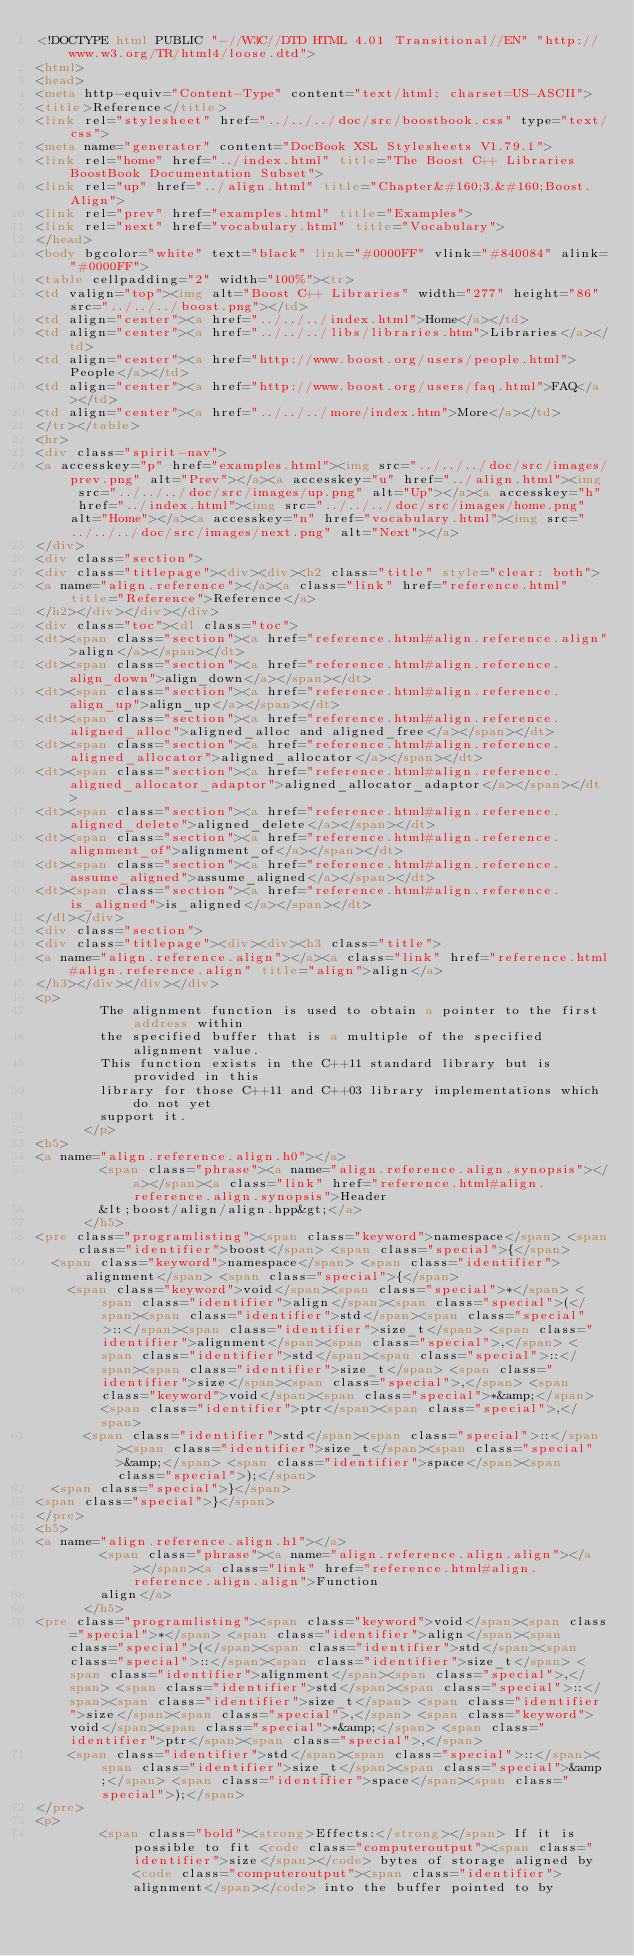Convert code to text. <code><loc_0><loc_0><loc_500><loc_500><_HTML_><!DOCTYPE html PUBLIC "-//W3C//DTD HTML 4.01 Transitional//EN" "http://www.w3.org/TR/html4/loose.dtd">
<html>
<head>
<meta http-equiv="Content-Type" content="text/html; charset=US-ASCII">
<title>Reference</title>
<link rel="stylesheet" href="../../../doc/src/boostbook.css" type="text/css">
<meta name="generator" content="DocBook XSL Stylesheets V1.79.1">
<link rel="home" href="../index.html" title="The Boost C++ Libraries BoostBook Documentation Subset">
<link rel="up" href="../align.html" title="Chapter&#160;3.&#160;Boost.Align">
<link rel="prev" href="examples.html" title="Examples">
<link rel="next" href="vocabulary.html" title="Vocabulary">
</head>
<body bgcolor="white" text="black" link="#0000FF" vlink="#840084" alink="#0000FF">
<table cellpadding="2" width="100%"><tr>
<td valign="top"><img alt="Boost C++ Libraries" width="277" height="86" src="../../../boost.png"></td>
<td align="center"><a href="../../../index.html">Home</a></td>
<td align="center"><a href="../../../libs/libraries.htm">Libraries</a></td>
<td align="center"><a href="http://www.boost.org/users/people.html">People</a></td>
<td align="center"><a href="http://www.boost.org/users/faq.html">FAQ</a></td>
<td align="center"><a href="../../../more/index.htm">More</a></td>
</tr></table>
<hr>
<div class="spirit-nav">
<a accesskey="p" href="examples.html"><img src="../../../doc/src/images/prev.png" alt="Prev"></a><a accesskey="u" href="../align.html"><img src="../../../doc/src/images/up.png" alt="Up"></a><a accesskey="h" href="../index.html"><img src="../../../doc/src/images/home.png" alt="Home"></a><a accesskey="n" href="vocabulary.html"><img src="../../../doc/src/images/next.png" alt="Next"></a>
</div>
<div class="section">
<div class="titlepage"><div><div><h2 class="title" style="clear: both">
<a name="align.reference"></a><a class="link" href="reference.html" title="Reference">Reference</a>
</h2></div></div></div>
<div class="toc"><dl class="toc">
<dt><span class="section"><a href="reference.html#align.reference.align">align</a></span></dt>
<dt><span class="section"><a href="reference.html#align.reference.align_down">align_down</a></span></dt>
<dt><span class="section"><a href="reference.html#align.reference.align_up">align_up</a></span></dt>
<dt><span class="section"><a href="reference.html#align.reference.aligned_alloc">aligned_alloc and aligned_free</a></span></dt>
<dt><span class="section"><a href="reference.html#align.reference.aligned_allocator">aligned_allocator</a></span></dt>
<dt><span class="section"><a href="reference.html#align.reference.aligned_allocator_adaptor">aligned_allocator_adaptor</a></span></dt>
<dt><span class="section"><a href="reference.html#align.reference.aligned_delete">aligned_delete</a></span></dt>
<dt><span class="section"><a href="reference.html#align.reference.alignment_of">alignment_of</a></span></dt>
<dt><span class="section"><a href="reference.html#align.reference.assume_aligned">assume_aligned</a></span></dt>
<dt><span class="section"><a href="reference.html#align.reference.is_aligned">is_aligned</a></span></dt>
</dl></div>
<div class="section">
<div class="titlepage"><div><div><h3 class="title">
<a name="align.reference.align"></a><a class="link" href="reference.html#align.reference.align" title="align">align</a>
</h3></div></div></div>
<p>
        The alignment function is used to obtain a pointer to the first address within
        the specified buffer that is a multiple of the specified alignment value.
        This function exists in the C++11 standard library but is provided in this
        library for those C++11 and C++03 library implementations which do not yet
        support it.
      </p>
<h5>
<a name="align.reference.align.h0"></a>
        <span class="phrase"><a name="align.reference.align.synopsis"></a></span><a class="link" href="reference.html#align.reference.align.synopsis">Header
        &lt;boost/align/align.hpp&gt;</a>
      </h5>
<pre class="programlisting"><span class="keyword">namespace</span> <span class="identifier">boost</span> <span class="special">{</span>
  <span class="keyword">namespace</span> <span class="identifier">alignment</span> <span class="special">{</span>
    <span class="keyword">void</span><span class="special">*</span> <span class="identifier">align</span><span class="special">(</span><span class="identifier">std</span><span class="special">::</span><span class="identifier">size_t</span> <span class="identifier">alignment</span><span class="special">,</span> <span class="identifier">std</span><span class="special">::</span><span class="identifier">size_t</span> <span class="identifier">size</span><span class="special">,</span> <span class="keyword">void</span><span class="special">*&amp;</span> <span class="identifier">ptr</span><span class="special">,</span>
      <span class="identifier">std</span><span class="special">::</span><span class="identifier">size_t</span><span class="special">&amp;</span> <span class="identifier">space</span><span class="special">);</span>
  <span class="special">}</span>
<span class="special">}</span>
</pre>
<h5>
<a name="align.reference.align.h1"></a>
        <span class="phrase"><a name="align.reference.align.align"></a></span><a class="link" href="reference.html#align.reference.align.align">Function
        align</a>
      </h5>
<pre class="programlisting"><span class="keyword">void</span><span class="special">*</span> <span class="identifier">align</span><span class="special">(</span><span class="identifier">std</span><span class="special">::</span><span class="identifier">size_t</span> <span class="identifier">alignment</span><span class="special">,</span> <span class="identifier">std</span><span class="special">::</span><span class="identifier">size_t</span> <span class="identifier">size</span><span class="special">,</span> <span class="keyword">void</span><span class="special">*&amp;</span> <span class="identifier">ptr</span><span class="special">,</span>
    <span class="identifier">std</span><span class="special">::</span><span class="identifier">size_t</span><span class="special">&amp;</span> <span class="identifier">space</span><span class="special">);</span>
</pre>
<p>
        <span class="bold"><strong>Effects:</strong></span> If it is possible to fit <code class="computeroutput"><span class="identifier">size</span></code> bytes of storage aligned by <code class="computeroutput"><span class="identifier">alignment</span></code> into the buffer pointed to by</code> 